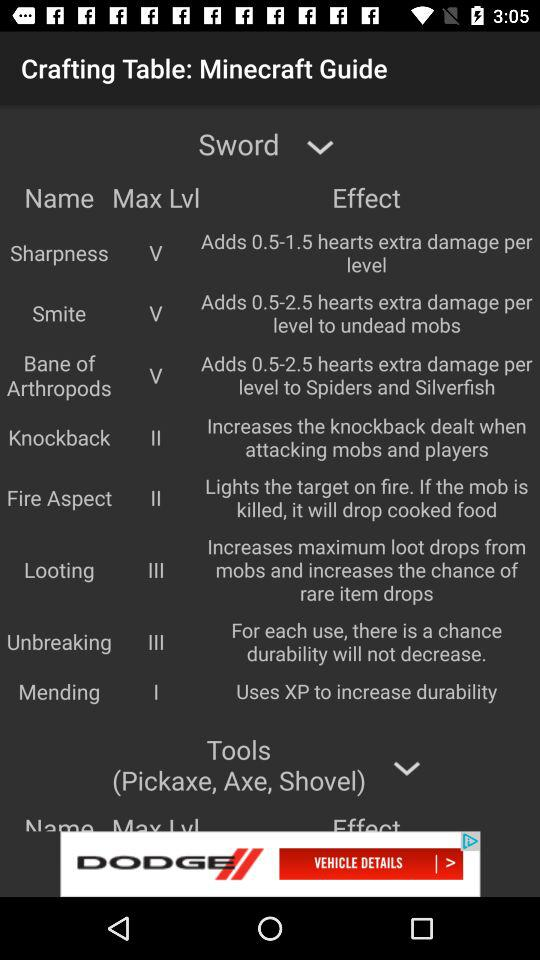What is the knockback maximum level? The knockback maximum level is II. 